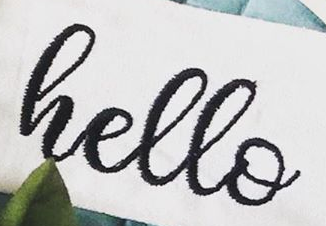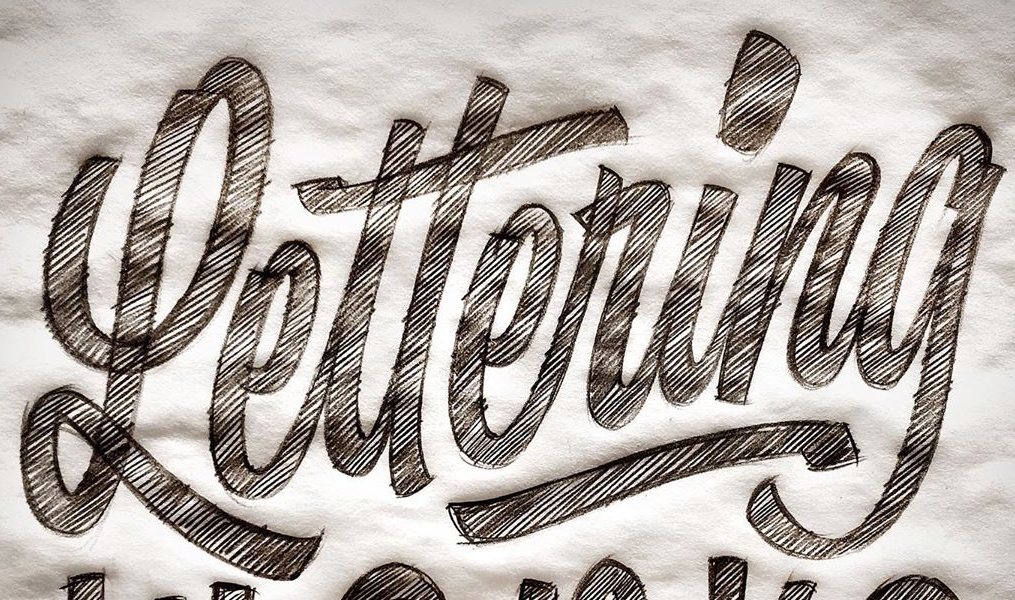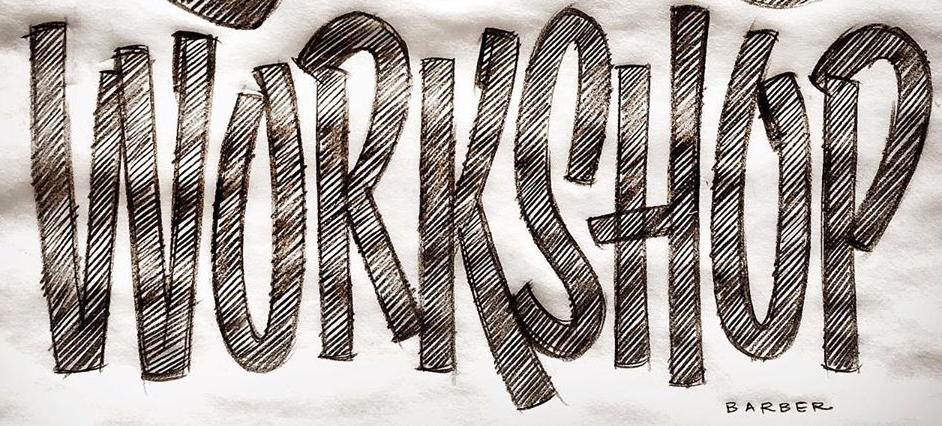Transcribe the words shown in these images in order, separated by a semicolon. hello; Lettering; WORKSHOP 